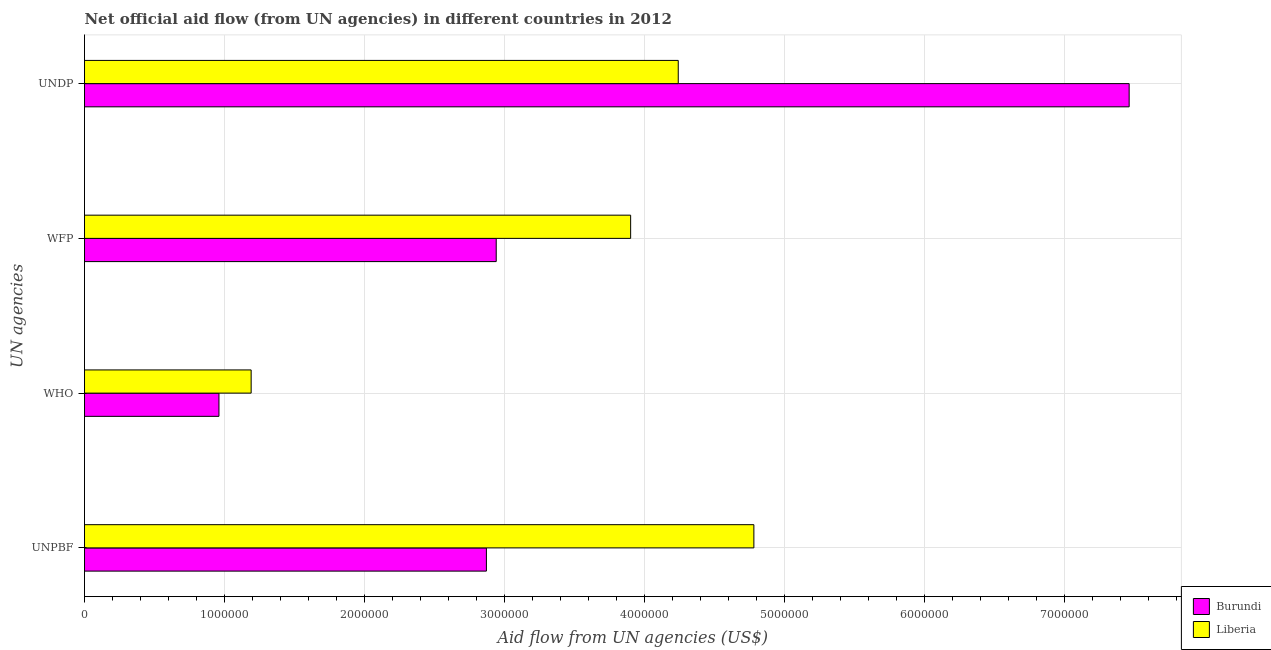How many groups of bars are there?
Your answer should be compact. 4. Are the number of bars on each tick of the Y-axis equal?
Ensure brevity in your answer.  Yes. How many bars are there on the 1st tick from the top?
Your answer should be very brief. 2. What is the label of the 4th group of bars from the top?
Keep it short and to the point. UNPBF. What is the amount of aid given by unpbf in Burundi?
Ensure brevity in your answer.  2.87e+06. Across all countries, what is the maximum amount of aid given by who?
Offer a very short reply. 1.19e+06. Across all countries, what is the minimum amount of aid given by who?
Your response must be concise. 9.60e+05. In which country was the amount of aid given by unpbf maximum?
Give a very brief answer. Liberia. In which country was the amount of aid given by wfp minimum?
Your response must be concise. Burundi. What is the total amount of aid given by wfp in the graph?
Offer a very short reply. 6.84e+06. What is the difference between the amount of aid given by unpbf in Burundi and that in Liberia?
Offer a terse response. -1.91e+06. What is the difference between the amount of aid given by who in Liberia and the amount of aid given by undp in Burundi?
Offer a very short reply. -6.27e+06. What is the average amount of aid given by wfp per country?
Offer a terse response. 3.42e+06. What is the difference between the amount of aid given by unpbf and amount of aid given by wfp in Burundi?
Ensure brevity in your answer.  -7.00e+04. In how many countries, is the amount of aid given by unpbf greater than 600000 US$?
Ensure brevity in your answer.  2. What is the ratio of the amount of aid given by wfp in Burundi to that in Liberia?
Offer a very short reply. 0.75. What is the difference between the highest and the second highest amount of aid given by undp?
Offer a terse response. 3.22e+06. What is the difference between the highest and the lowest amount of aid given by who?
Give a very brief answer. 2.30e+05. What does the 1st bar from the top in UNDP represents?
Provide a succinct answer. Liberia. What does the 2nd bar from the bottom in WHO represents?
Provide a succinct answer. Liberia. Are all the bars in the graph horizontal?
Offer a terse response. Yes. How many countries are there in the graph?
Make the answer very short. 2. Are the values on the major ticks of X-axis written in scientific E-notation?
Offer a very short reply. No. Does the graph contain any zero values?
Make the answer very short. No. How many legend labels are there?
Your answer should be very brief. 2. What is the title of the graph?
Provide a short and direct response. Net official aid flow (from UN agencies) in different countries in 2012. What is the label or title of the X-axis?
Ensure brevity in your answer.  Aid flow from UN agencies (US$). What is the label or title of the Y-axis?
Give a very brief answer. UN agencies. What is the Aid flow from UN agencies (US$) in Burundi in UNPBF?
Provide a succinct answer. 2.87e+06. What is the Aid flow from UN agencies (US$) of Liberia in UNPBF?
Keep it short and to the point. 4.78e+06. What is the Aid flow from UN agencies (US$) in Burundi in WHO?
Offer a very short reply. 9.60e+05. What is the Aid flow from UN agencies (US$) in Liberia in WHO?
Provide a succinct answer. 1.19e+06. What is the Aid flow from UN agencies (US$) in Burundi in WFP?
Your response must be concise. 2.94e+06. What is the Aid flow from UN agencies (US$) of Liberia in WFP?
Give a very brief answer. 3.90e+06. What is the Aid flow from UN agencies (US$) in Burundi in UNDP?
Ensure brevity in your answer.  7.46e+06. What is the Aid flow from UN agencies (US$) in Liberia in UNDP?
Offer a very short reply. 4.24e+06. Across all UN agencies, what is the maximum Aid flow from UN agencies (US$) of Burundi?
Provide a short and direct response. 7.46e+06. Across all UN agencies, what is the maximum Aid flow from UN agencies (US$) in Liberia?
Keep it short and to the point. 4.78e+06. Across all UN agencies, what is the minimum Aid flow from UN agencies (US$) of Burundi?
Your answer should be very brief. 9.60e+05. Across all UN agencies, what is the minimum Aid flow from UN agencies (US$) in Liberia?
Ensure brevity in your answer.  1.19e+06. What is the total Aid flow from UN agencies (US$) of Burundi in the graph?
Your answer should be very brief. 1.42e+07. What is the total Aid flow from UN agencies (US$) of Liberia in the graph?
Your answer should be compact. 1.41e+07. What is the difference between the Aid flow from UN agencies (US$) of Burundi in UNPBF and that in WHO?
Make the answer very short. 1.91e+06. What is the difference between the Aid flow from UN agencies (US$) in Liberia in UNPBF and that in WHO?
Make the answer very short. 3.59e+06. What is the difference between the Aid flow from UN agencies (US$) in Liberia in UNPBF and that in WFP?
Ensure brevity in your answer.  8.80e+05. What is the difference between the Aid flow from UN agencies (US$) in Burundi in UNPBF and that in UNDP?
Give a very brief answer. -4.59e+06. What is the difference between the Aid flow from UN agencies (US$) in Liberia in UNPBF and that in UNDP?
Ensure brevity in your answer.  5.40e+05. What is the difference between the Aid flow from UN agencies (US$) in Burundi in WHO and that in WFP?
Your answer should be very brief. -1.98e+06. What is the difference between the Aid flow from UN agencies (US$) in Liberia in WHO and that in WFP?
Your answer should be compact. -2.71e+06. What is the difference between the Aid flow from UN agencies (US$) in Burundi in WHO and that in UNDP?
Offer a very short reply. -6.50e+06. What is the difference between the Aid flow from UN agencies (US$) of Liberia in WHO and that in UNDP?
Give a very brief answer. -3.05e+06. What is the difference between the Aid flow from UN agencies (US$) of Burundi in WFP and that in UNDP?
Provide a short and direct response. -4.52e+06. What is the difference between the Aid flow from UN agencies (US$) of Liberia in WFP and that in UNDP?
Offer a terse response. -3.40e+05. What is the difference between the Aid flow from UN agencies (US$) in Burundi in UNPBF and the Aid flow from UN agencies (US$) in Liberia in WHO?
Provide a short and direct response. 1.68e+06. What is the difference between the Aid flow from UN agencies (US$) of Burundi in UNPBF and the Aid flow from UN agencies (US$) of Liberia in WFP?
Offer a very short reply. -1.03e+06. What is the difference between the Aid flow from UN agencies (US$) of Burundi in UNPBF and the Aid flow from UN agencies (US$) of Liberia in UNDP?
Make the answer very short. -1.37e+06. What is the difference between the Aid flow from UN agencies (US$) in Burundi in WHO and the Aid flow from UN agencies (US$) in Liberia in WFP?
Ensure brevity in your answer.  -2.94e+06. What is the difference between the Aid flow from UN agencies (US$) of Burundi in WHO and the Aid flow from UN agencies (US$) of Liberia in UNDP?
Offer a terse response. -3.28e+06. What is the difference between the Aid flow from UN agencies (US$) in Burundi in WFP and the Aid flow from UN agencies (US$) in Liberia in UNDP?
Ensure brevity in your answer.  -1.30e+06. What is the average Aid flow from UN agencies (US$) in Burundi per UN agencies?
Keep it short and to the point. 3.56e+06. What is the average Aid flow from UN agencies (US$) of Liberia per UN agencies?
Your response must be concise. 3.53e+06. What is the difference between the Aid flow from UN agencies (US$) in Burundi and Aid flow from UN agencies (US$) in Liberia in UNPBF?
Your response must be concise. -1.91e+06. What is the difference between the Aid flow from UN agencies (US$) in Burundi and Aid flow from UN agencies (US$) in Liberia in WFP?
Your answer should be compact. -9.60e+05. What is the difference between the Aid flow from UN agencies (US$) of Burundi and Aid flow from UN agencies (US$) of Liberia in UNDP?
Keep it short and to the point. 3.22e+06. What is the ratio of the Aid flow from UN agencies (US$) of Burundi in UNPBF to that in WHO?
Offer a very short reply. 2.99. What is the ratio of the Aid flow from UN agencies (US$) in Liberia in UNPBF to that in WHO?
Your response must be concise. 4.02. What is the ratio of the Aid flow from UN agencies (US$) in Burundi in UNPBF to that in WFP?
Ensure brevity in your answer.  0.98. What is the ratio of the Aid flow from UN agencies (US$) in Liberia in UNPBF to that in WFP?
Your answer should be compact. 1.23. What is the ratio of the Aid flow from UN agencies (US$) of Burundi in UNPBF to that in UNDP?
Your response must be concise. 0.38. What is the ratio of the Aid flow from UN agencies (US$) of Liberia in UNPBF to that in UNDP?
Your answer should be compact. 1.13. What is the ratio of the Aid flow from UN agencies (US$) in Burundi in WHO to that in WFP?
Your response must be concise. 0.33. What is the ratio of the Aid flow from UN agencies (US$) of Liberia in WHO to that in WFP?
Offer a very short reply. 0.31. What is the ratio of the Aid flow from UN agencies (US$) in Burundi in WHO to that in UNDP?
Provide a short and direct response. 0.13. What is the ratio of the Aid flow from UN agencies (US$) in Liberia in WHO to that in UNDP?
Your answer should be compact. 0.28. What is the ratio of the Aid flow from UN agencies (US$) in Burundi in WFP to that in UNDP?
Your answer should be very brief. 0.39. What is the ratio of the Aid flow from UN agencies (US$) in Liberia in WFP to that in UNDP?
Offer a terse response. 0.92. What is the difference between the highest and the second highest Aid flow from UN agencies (US$) in Burundi?
Provide a short and direct response. 4.52e+06. What is the difference between the highest and the second highest Aid flow from UN agencies (US$) of Liberia?
Your answer should be very brief. 5.40e+05. What is the difference between the highest and the lowest Aid flow from UN agencies (US$) of Burundi?
Offer a terse response. 6.50e+06. What is the difference between the highest and the lowest Aid flow from UN agencies (US$) in Liberia?
Make the answer very short. 3.59e+06. 